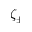<formula> <loc_0><loc_0><loc_500><loc_500>\zeta _ { \pm }</formula> 